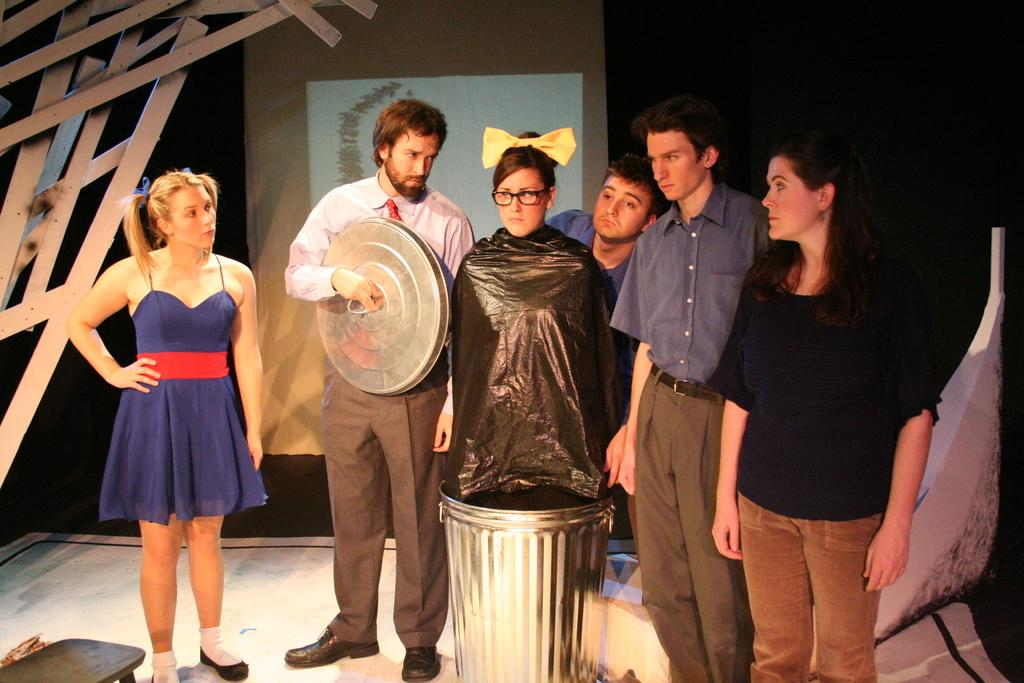How many people are in the image? There is a group of people standing in the image. What is one person doing with a dustbin? One person is holding the lid of a dustbin. What is another person doing in relation to the dustbin? Another person is standing inside the dustbin. What can be seen on the screen in the image? The facts do not provide information about the screen's content. What type of furniture is present in the image? There is a stool in the image. What type of baseball equipment can be seen in the image? There is no baseball equipment present in the image. What is the limit of the person's mind in the image? The facts do not provide information about the person's mind or any limits associated with it. 